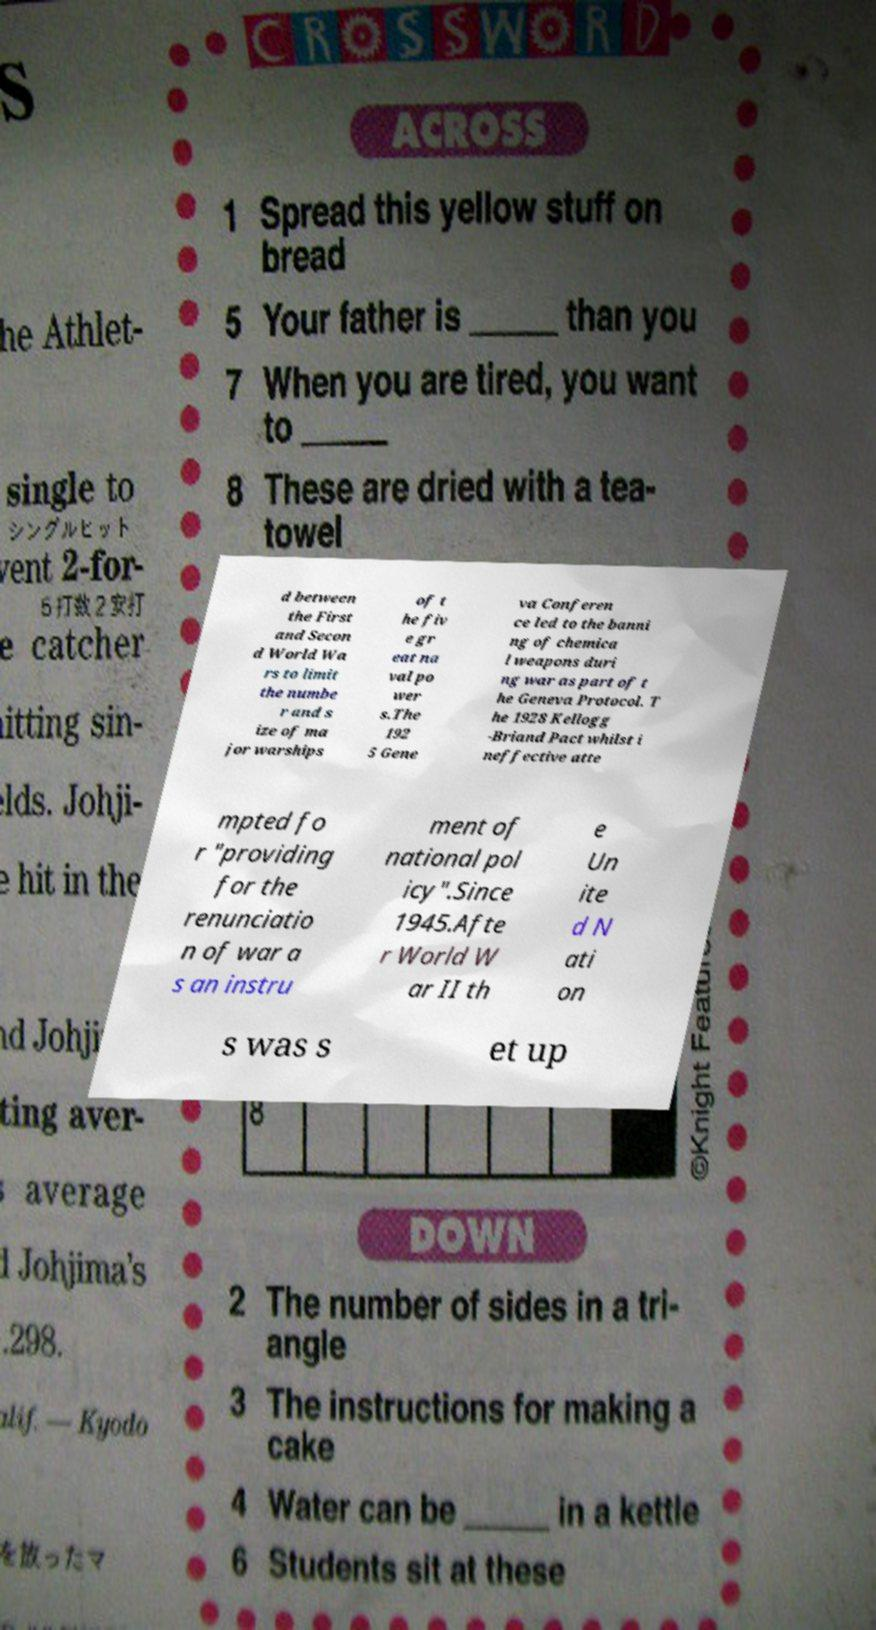What messages or text are displayed in this image? I need them in a readable, typed format. d between the First and Secon d World Wa rs to limit the numbe r and s ize of ma jor warships of t he fiv e gr eat na val po wer s.The 192 5 Gene va Conferen ce led to the banni ng of chemica l weapons duri ng war as part of t he Geneva Protocol. T he 1928 Kellogg -Briand Pact whilst i neffective atte mpted fo r "providing for the renunciatio n of war a s an instru ment of national pol icy".Since 1945.Afte r World W ar II th e Un ite d N ati on s was s et up 